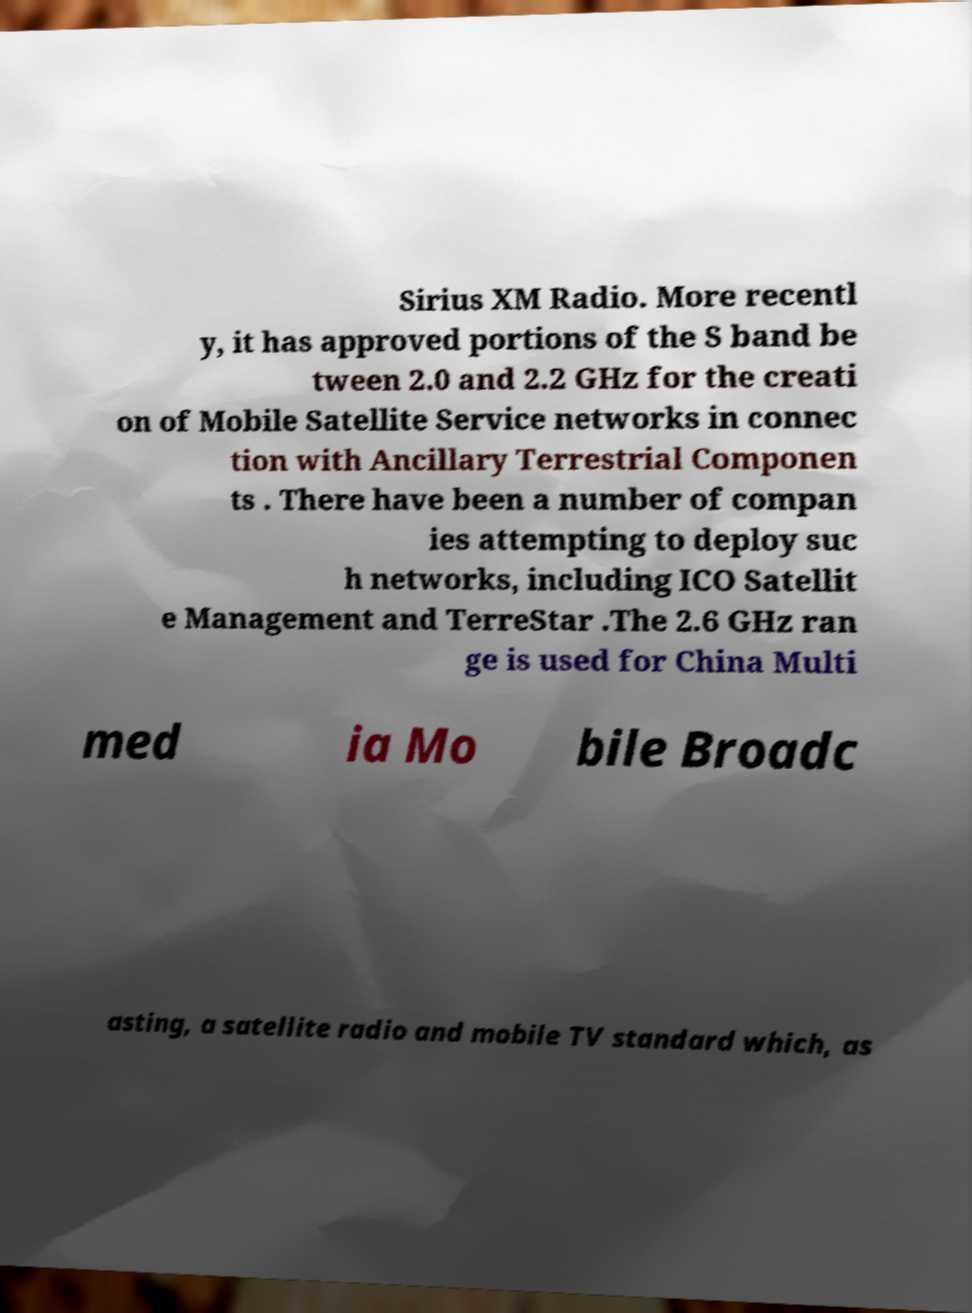Please read and relay the text visible in this image. What does it say? Sirius XM Radio. More recentl y, it has approved portions of the S band be tween 2.0 and 2.2 GHz for the creati on of Mobile Satellite Service networks in connec tion with Ancillary Terrestrial Componen ts . There have been a number of compan ies attempting to deploy suc h networks, including ICO Satellit e Management and TerreStar .The 2.6 GHz ran ge is used for China Multi med ia Mo bile Broadc asting, a satellite radio and mobile TV standard which, as 